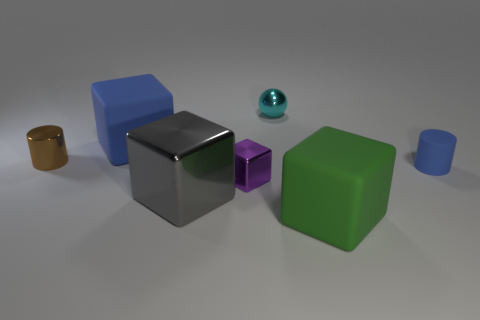What is the size of the gray shiny block?
Your response must be concise. Large. How many purple metallic blocks have the same size as the brown thing?
Make the answer very short. 1. How many big green matte things have the same shape as the large blue object?
Offer a terse response. 1. Are there an equal number of small blue objects that are to the left of the tiny blue matte object and blue things?
Provide a short and direct response. No. Is there any other thing that is the same size as the cyan shiny thing?
Your answer should be compact. Yes. The brown object that is the same size as the purple block is what shape?
Offer a terse response. Cylinder. Are there any other brown metal objects of the same shape as the tiny brown thing?
Your answer should be very brief. No. Are there any brown objects that are on the right side of the tiny object that is behind the matte thing on the left side of the green object?
Ensure brevity in your answer.  No. Are there more small cyan things that are in front of the big gray block than tiny rubber things on the right side of the small metallic sphere?
Provide a succinct answer. No. There is a cyan object that is the same size as the purple shiny thing; what material is it?
Your answer should be compact. Metal. 